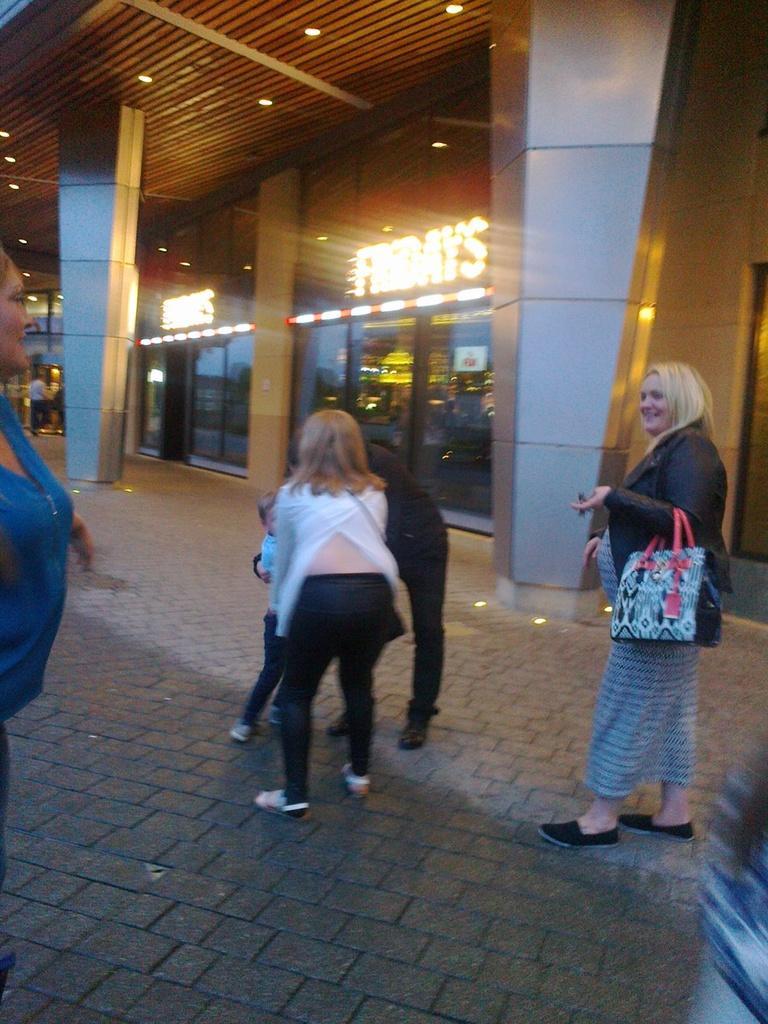How would you summarize this image in a sentence or two? The picture is taken outside a city. In the foreground of the picture there are people standing. In the background there is a building. In the center of the background there are lights. At the top to the ceiling there are lights. 